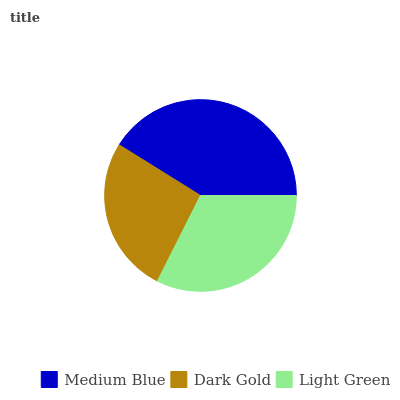Is Dark Gold the minimum?
Answer yes or no. Yes. Is Medium Blue the maximum?
Answer yes or no. Yes. Is Light Green the minimum?
Answer yes or no. No. Is Light Green the maximum?
Answer yes or no. No. Is Light Green greater than Dark Gold?
Answer yes or no. Yes. Is Dark Gold less than Light Green?
Answer yes or no. Yes. Is Dark Gold greater than Light Green?
Answer yes or no. No. Is Light Green less than Dark Gold?
Answer yes or no. No. Is Light Green the high median?
Answer yes or no. Yes. Is Light Green the low median?
Answer yes or no. Yes. Is Dark Gold the high median?
Answer yes or no. No. Is Medium Blue the low median?
Answer yes or no. No. 